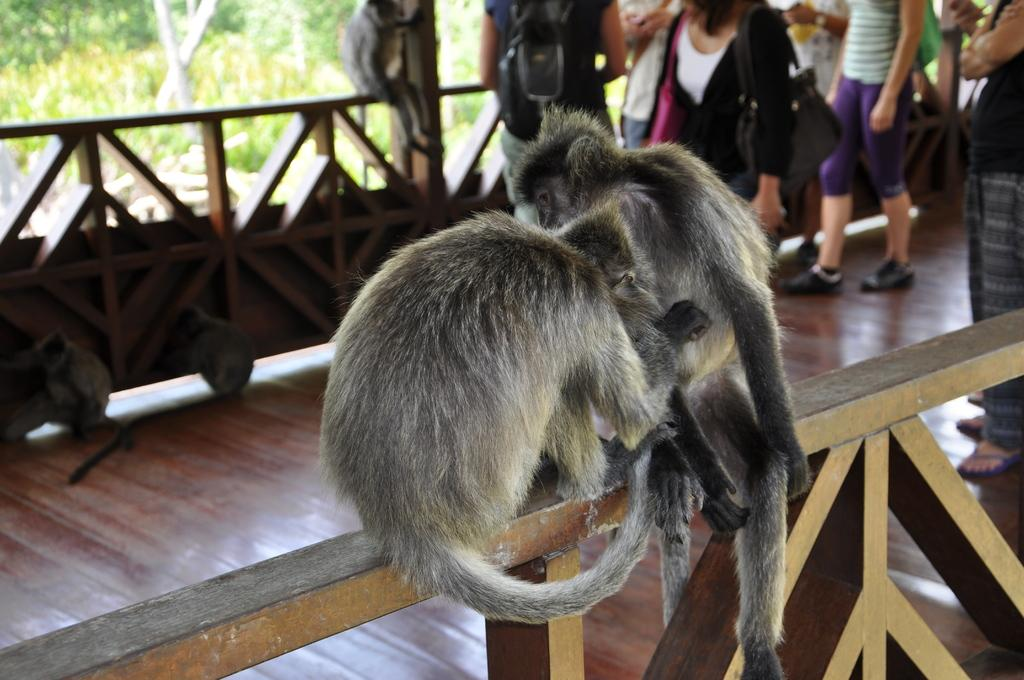How many monkeys are in the image? There are 2 monkeys in the image. What are the monkeys doing in the image? The monkeys are standing on a wooden wall. What else can be seen in the image besides the monkeys? There are people walking in the image. Where are the trees located in the image? The trees are visible in the left side of the image, and they are located far in the background. What type of popcorn is being produced by the monkeys in the image? There is no popcorn present in the image, and the monkeys are not producing anything. 